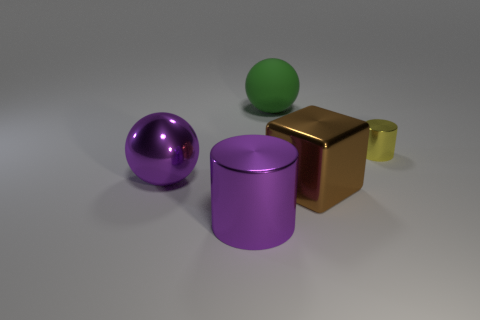The cylinder that is the same material as the tiny yellow thing is what color?
Your answer should be compact. Purple. There is a big thing to the right of the large sphere that is right of the sphere that is in front of the big green thing; what is its shape?
Provide a succinct answer. Cube. How big is the purple cylinder?
Offer a terse response. Large. What shape is the large brown object that is the same material as the large cylinder?
Give a very brief answer. Cube. Is the number of large green matte spheres that are in front of the big green thing less than the number of big purple things?
Make the answer very short. Yes. What color is the large metallic thing in front of the large cube?
Ensure brevity in your answer.  Purple. There is a ball that is the same color as the large cylinder; what material is it?
Provide a succinct answer. Metal. Is there a small brown metallic thing that has the same shape as the large brown object?
Keep it short and to the point. No. What number of other big brown objects have the same shape as the rubber object?
Keep it short and to the point. 0. Does the large rubber ball have the same color as the large cylinder?
Provide a succinct answer. No. 